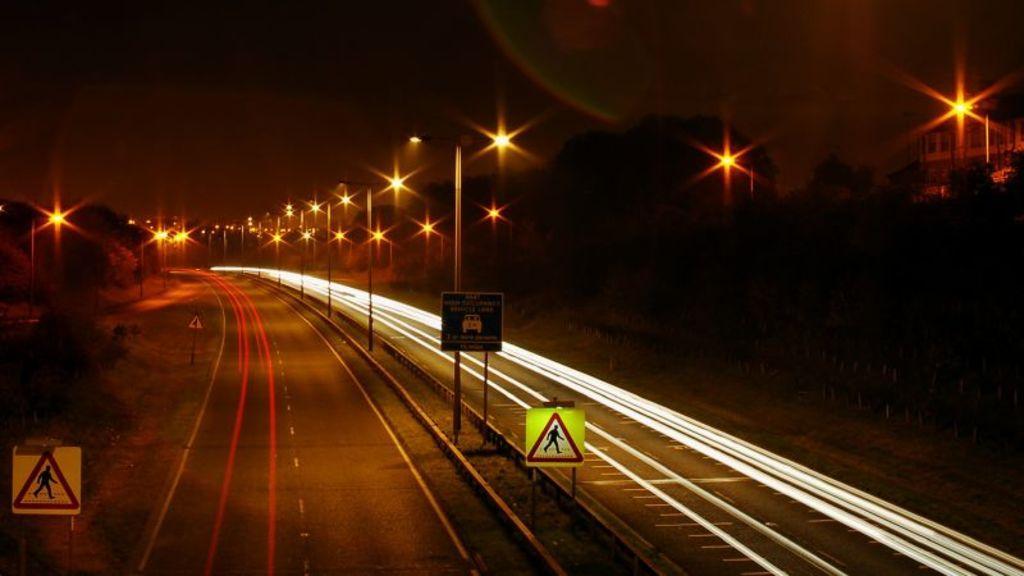In one or two sentences, can you explain what this image depicts? This image is taken in the dark where we can see the roads, caution boards, light poles, trees and the dark sky in the background. 